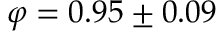Convert formula to latex. <formula><loc_0><loc_0><loc_500><loc_500>\varphi = 0 . 9 5 \pm 0 . 0 9</formula> 